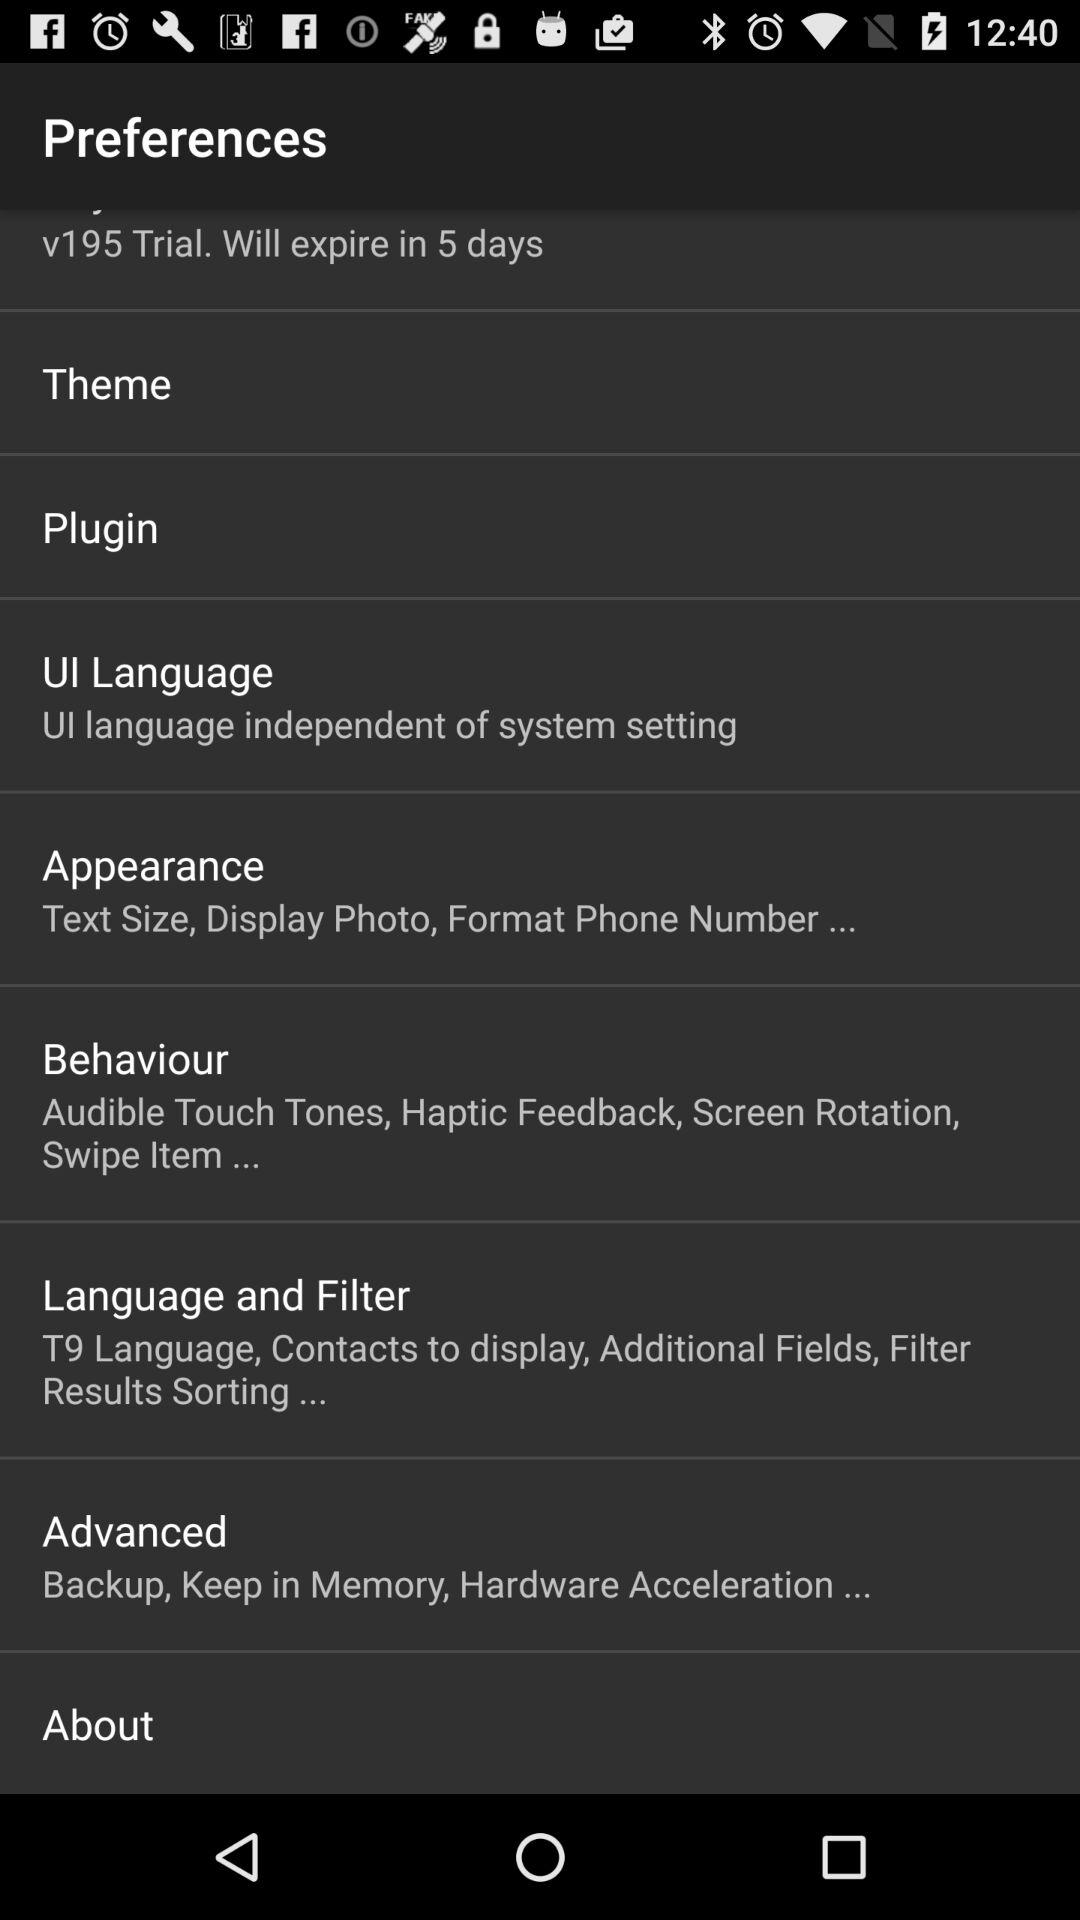In how many days will the trial of V195 expire? It will expire in 5 days. 